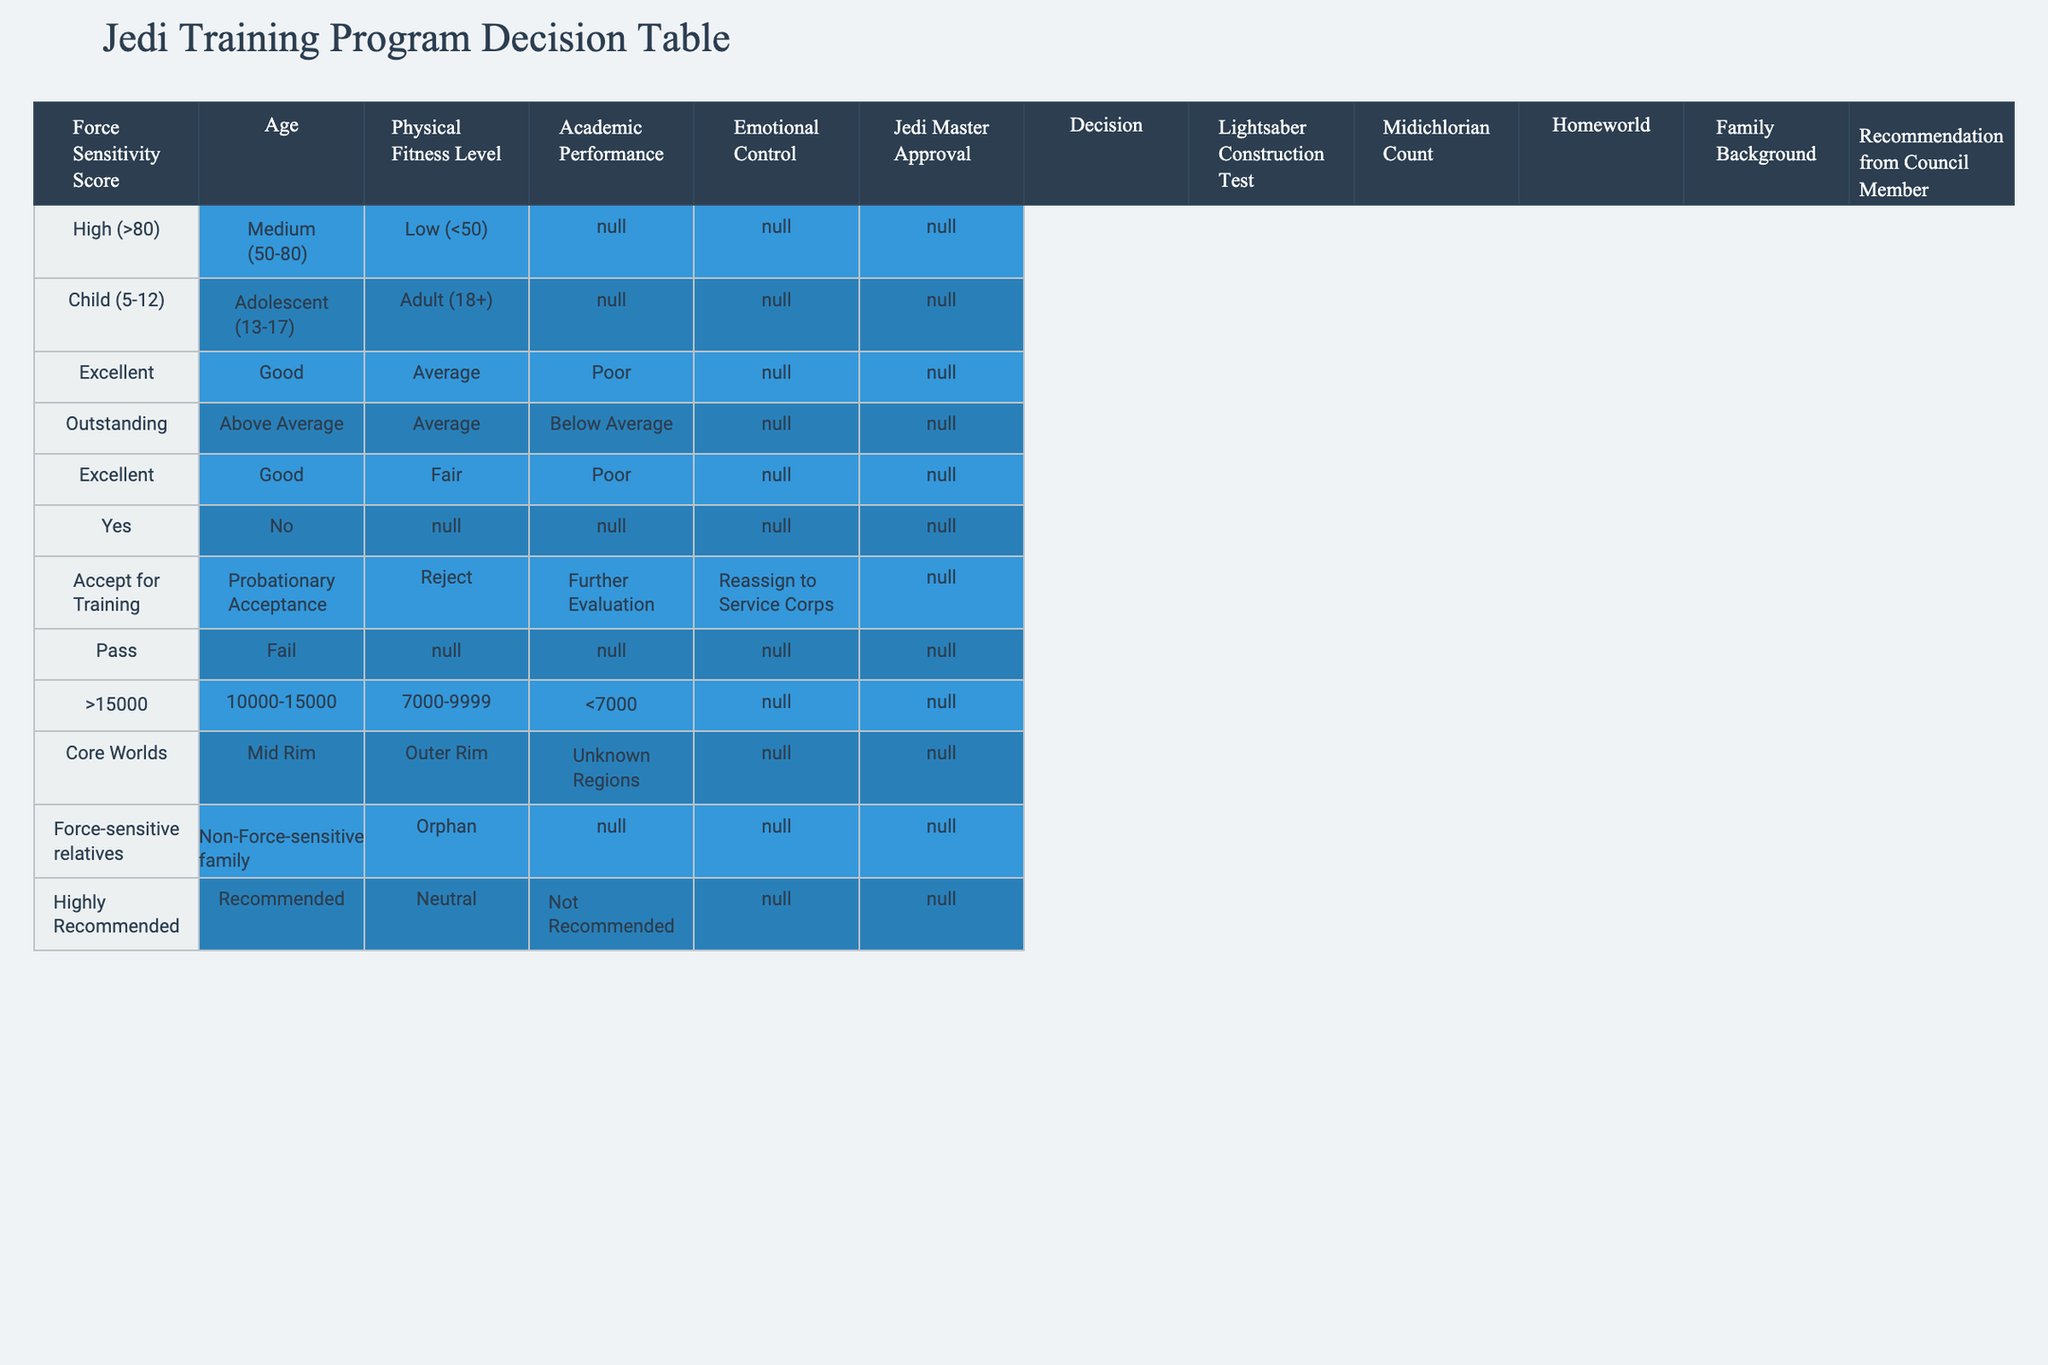What is the recommendation for someone with High Force Sensitivity and Excellent Emotional Control? According to the table, those with High Force Sensitivity are likely to receive an "Accept for Training" recommendation, and since Excellent Emotional Control also supports this category, the recommendation remains unchanged.
Answer: Accept for Training How many categories are considered to assess the Jedi training recommendations? The table lists four main categories that define recommendations: Force Sensitivity, Age, Physical Fitness, Academic Performance, and Emotional Control, totaling five distinct categories for assessment.
Answer: Five Is a Jedi Master’s approval necessary for accepting a candidate into the training program? Based on the data in the table, there is a distinct 'Yes' or 'No' indication for Jedi Master Approval, but it does not directly relate to the acceptance recommendation, implying it's not strictly necessary but beneficial.
Answer: No What is the average Midichlorian Count for an adult with Good Physical Fitness and Fair Emotional Control? Referring to the table, adults with Good Physical Fitness fall within the Midichlorian Count of 10,000-15,000. Fair Emotional Control does not alter this factor, hence it remains the same. The average is within this range but is not explicitly defined.
Answer: 10,000-15,000 Can someone with an Outstanding Academic Performance and Low Physical Fitness still be accepted into training? An Outstanding Academic Performance is very favorable; however, Low Physical Fitness alone likely leads to a rejection status without examining other factors, meaning they would require further evaluation to consider acceptance.
Answer: Further Evaluation What steps need to be taken to accept someone with Average Emotional Control and Poor Physical Fitness? Given the conditions, we first assess the emotional control and physical fitness levels. An Average level of Emotional Control does not guarantee acceptance, nor does Poor Physical Fitness, which leads to a recommendation for further evaluation and not an outright acceptance.
Answer: Further Evaluation How does having Force-sensitive relatives impact the final decision of the recommendation? The presence of Force-sensitive relatives in an individual positively affects the decision-making process, likely leading to a recommended status which may outweigh other negative factors, but the final recommendation would still depend on all assessed criteria.
Answer: Positive Impact If someone is from the Outer Rim and categorized as an Adolescent with Fair Emotional Control, what is the result? The Outer Rim designation does not directly influence the recommendation; however, as an Adolescent with Fair Emotional Control, they likely fall toward the lower end of the acceptance spectrum, necessitating reevaluation, hence leading to a conclusion of further evaluation needed.
Answer: Further Evaluation 